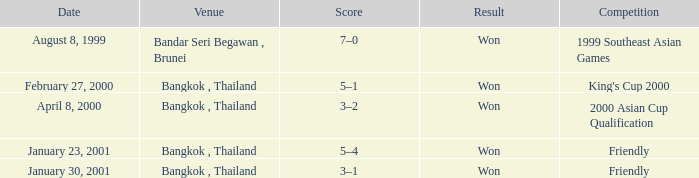What was the result from the 2000 asian cup qualification? Won. 